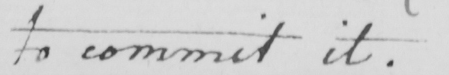Transcribe the text shown in this historical manuscript line. to commit it . 